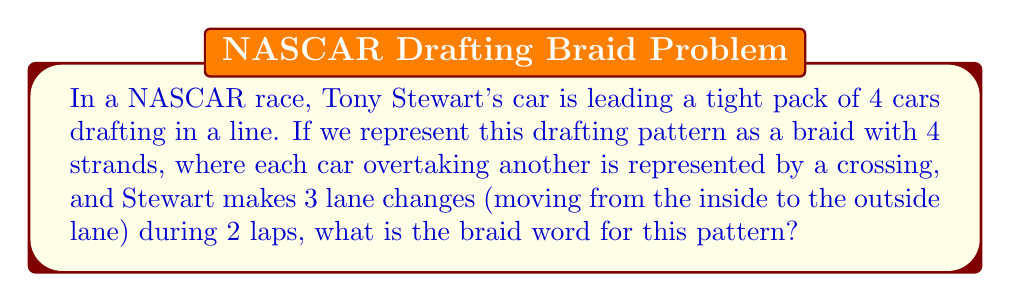What is the answer to this math problem? Let's approach this step-by-step:

1) In braid theory, we number the strands from left to right. Let's assign Tony Stewart's car to strand 1 initially.

2) A positive crossing $\sigma_i$ means the $i$-th strand crosses over the $(i+1)$-th strand from left to right.

3) Stewart makes 3 lane changes from inside to outside over 2 laps. This means he'll move from position 1 to 4 gradually.

4) His moves can be represented as follows:
   - Move from 1 to 2: $\sigma_1$
   - Move from 2 to 3: $\sigma_2$
   - Move from 3 to 4: $\sigma_3$

5) The full sequence of moves is: $\sigma_1 \sigma_2 \sigma_3$

6) In braid theory, we write the operations from left to right in the order they occur.

Therefore, the braid word representing this drafting pattern is $\sigma_1 \sigma_2 \sigma_3$.
Answer: $\sigma_1 \sigma_2 \sigma_3$ 